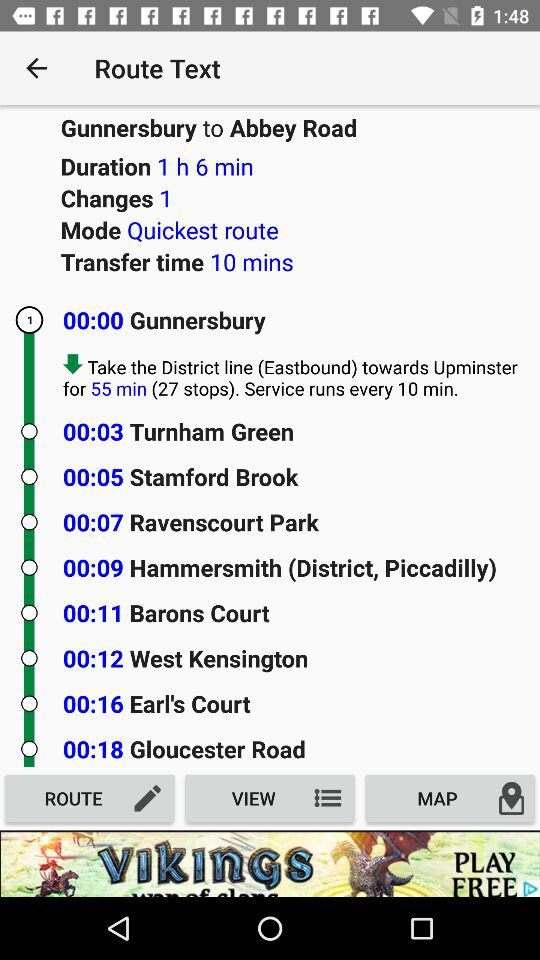What is the frequency of services provided? The frequency of service provided is every 10 minutes. 